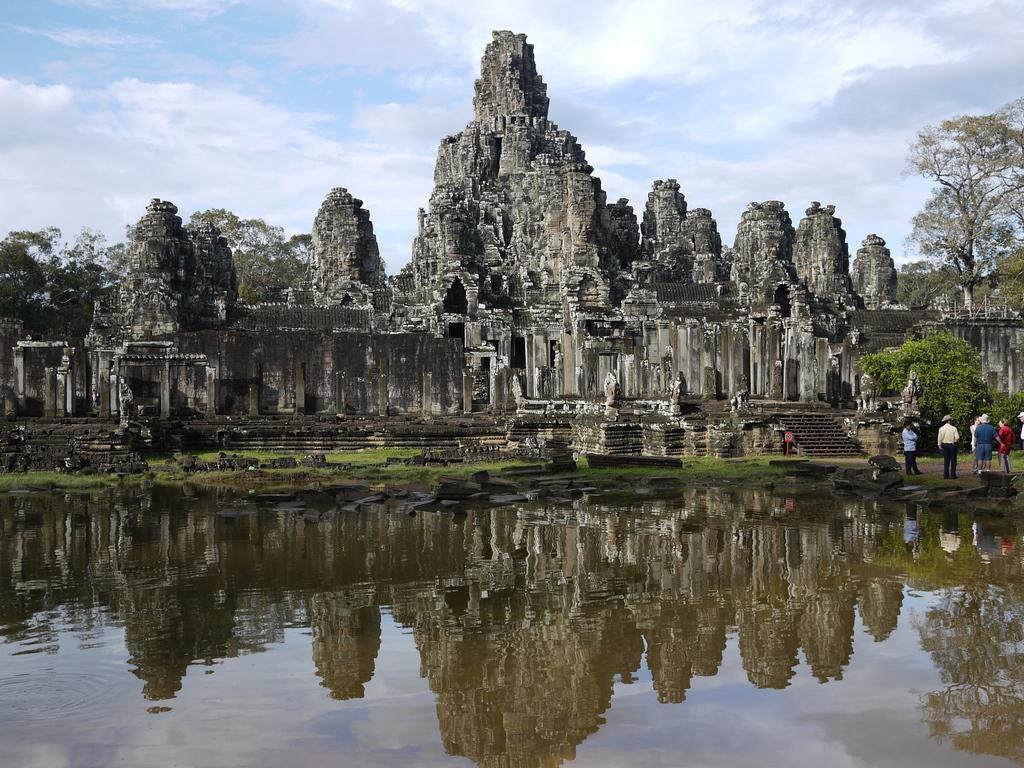In one or two sentences, can you explain what this image depicts? In this image, we can see water and there are some people standing on the ground, we can see some stairs and there are some trees, we can see an ancient architecture. 